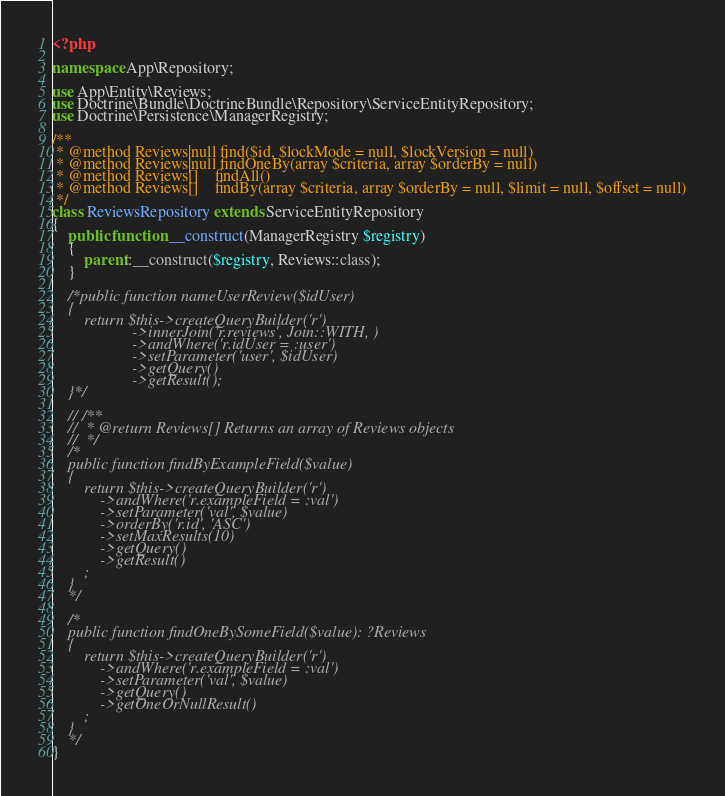<code> <loc_0><loc_0><loc_500><loc_500><_PHP_><?php

namespace App\Repository;

use App\Entity\Reviews;
use Doctrine\Bundle\DoctrineBundle\Repository\ServiceEntityRepository;
use Doctrine\Persistence\ManagerRegistry;

/**
 * @method Reviews|null find($id, $lockMode = null, $lockVersion = null)
 * @method Reviews|null findOneBy(array $criteria, array $orderBy = null)
 * @method Reviews[]    findAll()
 * @method Reviews[]    findBy(array $criteria, array $orderBy = null, $limit = null, $offset = null)
 */
class ReviewsRepository extends ServiceEntityRepository
{
    public function __construct(ManagerRegistry $registry)
    {
        parent::__construct($registry, Reviews::class);
    }

    /*public function nameUserReview($idUser)
    {
        return $this->createQueryBuilder('r')
                    ->innerJoin('r.reviews', Join::WITH, )
                    ->andWhere('r.idUser = :user')
                    ->setParameter('user', $idUser)
                    ->getQuery()
                    ->getResult();
    }*/

    // /**
    //  * @return Reviews[] Returns an array of Reviews objects
    //  */
    /*
    public function findByExampleField($value)
    {
        return $this->createQueryBuilder('r')
            ->andWhere('r.exampleField = :val')
            ->setParameter('val', $value)
            ->orderBy('r.id', 'ASC')
            ->setMaxResults(10)
            ->getQuery()
            ->getResult()
        ;
    }
    */

    /*
    public function findOneBySomeField($value): ?Reviews
    {
        return $this->createQueryBuilder('r')
            ->andWhere('r.exampleField = :val')
            ->setParameter('val', $value)
            ->getQuery()
            ->getOneOrNullResult()
        ;
    }
    */
}
</code> 